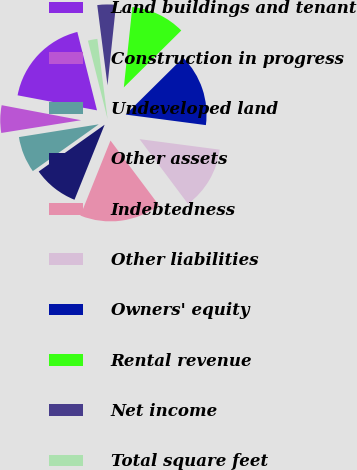Convert chart. <chart><loc_0><loc_0><loc_500><loc_500><pie_chart><fcel>Land buildings and tenant<fcel>Construction in progress<fcel>Undeveloped land<fcel>Other assets<fcel>Indebtedness<fcel>Other liabilities<fcel>Owners' equity<fcel>Rental revenue<fcel>Net income<fcel>Total square feet<nl><fcel>18.11%<fcel>5.5%<fcel>7.3%<fcel>9.1%<fcel>16.3%<fcel>12.7%<fcel>14.5%<fcel>10.9%<fcel>3.7%<fcel>1.89%<nl></chart> 